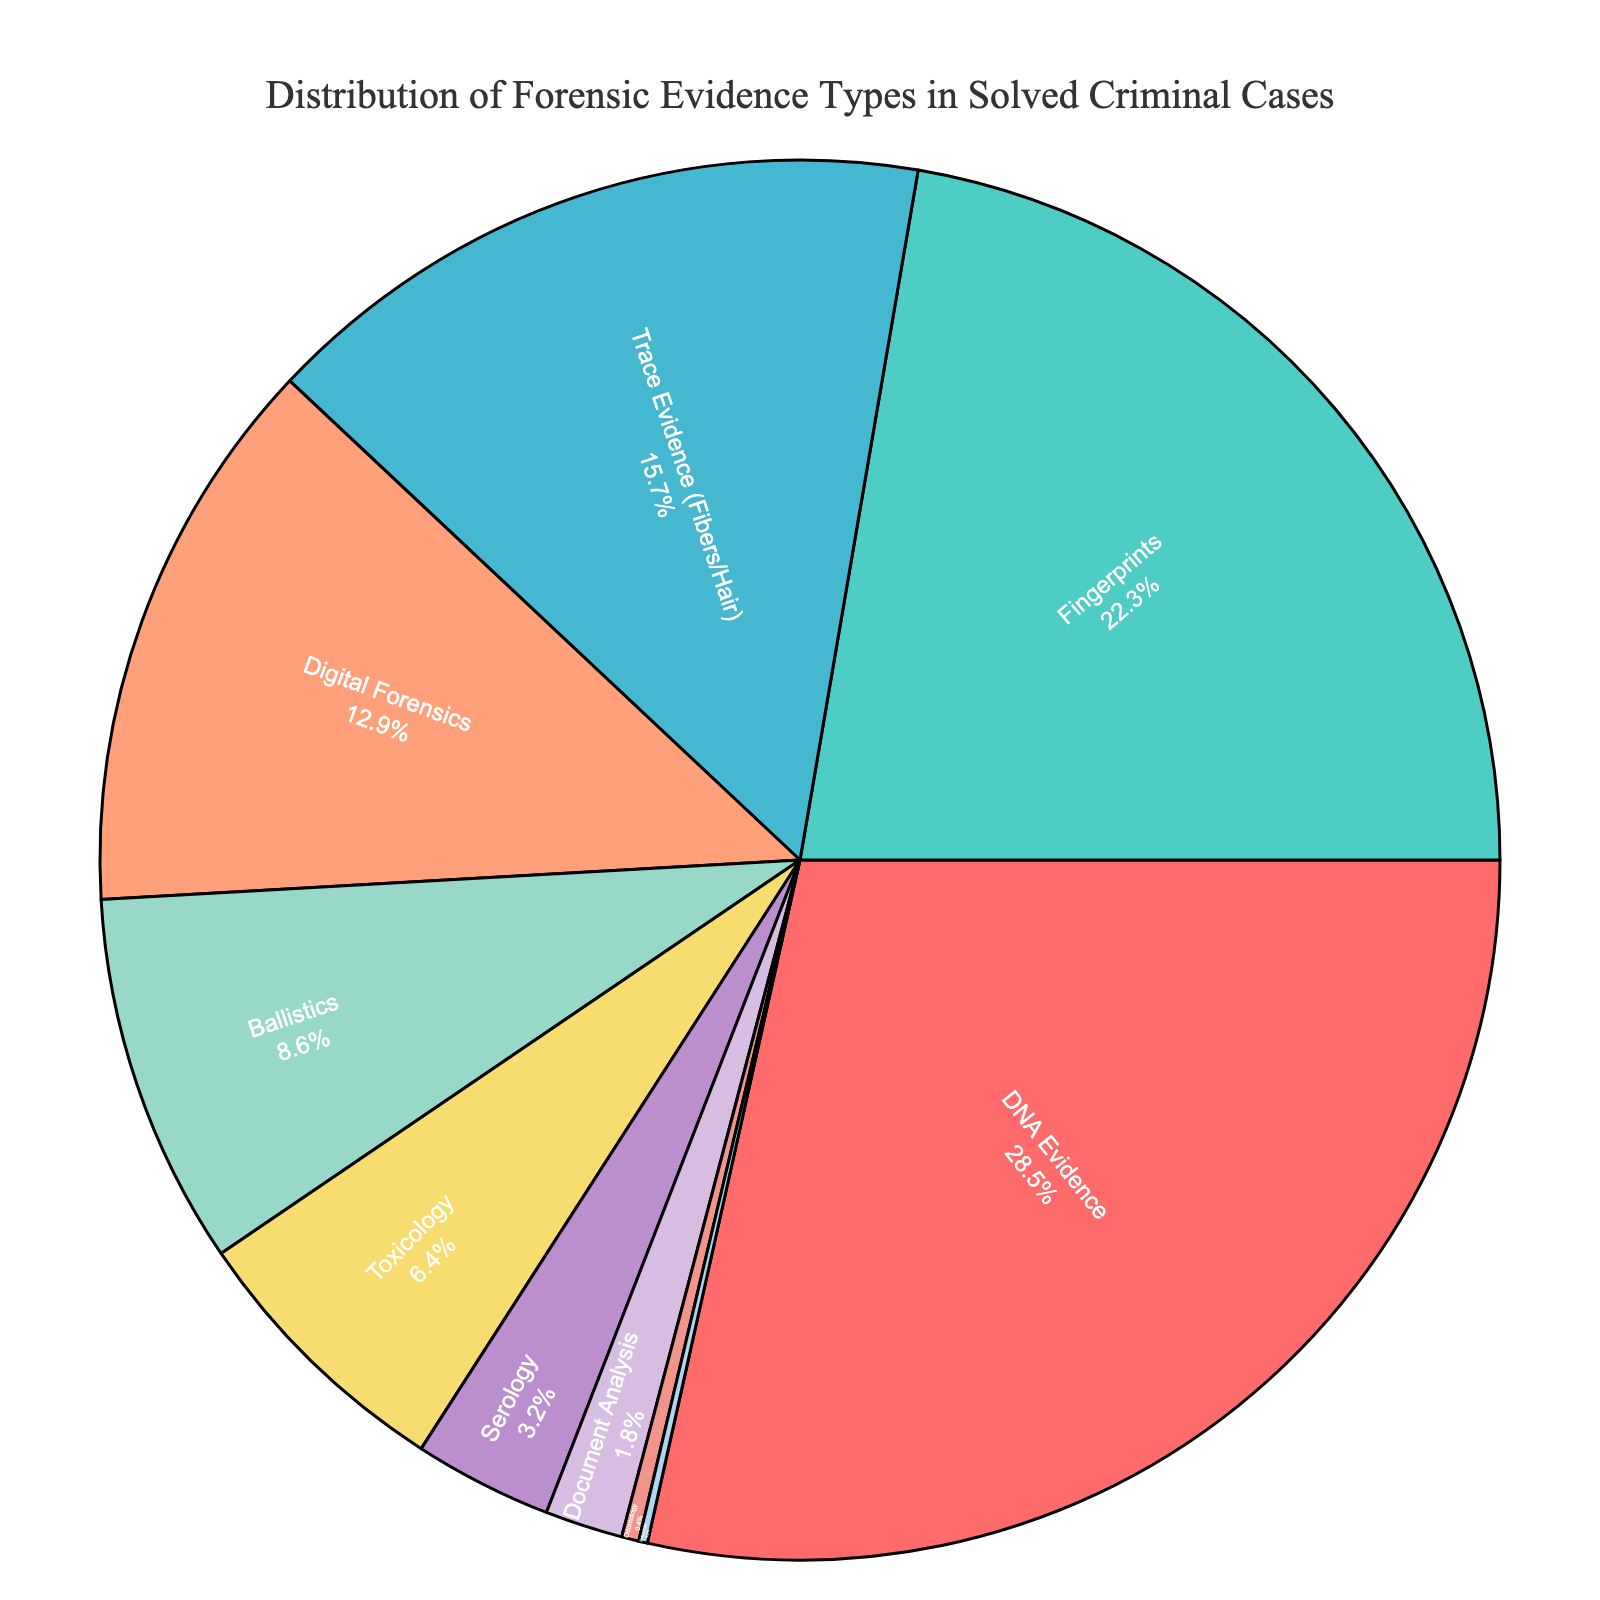What's the largest segment in the pie chart? The largest segment in the pie chart is represented by DNA Evidence, which has the highest percentage. This can be visually identified as the largest slice.
Answer: DNA Evidence Which evidence types have percentages greater than 20%? To identify percentages greater than 20%, you need to look at the labels and associated percentages on the pie chart. DNA Evidence (28.5%) and Fingerprints (22.3%) are the segments with percentages greater than 20%.
Answer: DNA Evidence, Fingerprints Which evidence type is represented by the smallest slice in the pie chart? The smallest slice in the pie chart is represented by Entomology, which has the lowest percentage at 0.2%. This can be visually identified as the smallest segment.
Answer: Entomology What is the combined percentage of Trace Evidence and Digital Forensics? To find the combined percentage, add the percentages of Trace Evidence (15.7%) and Digital Forensics (12.9%): 15.7 + 12.9 = 28.6%
Answer: 28.6% How does the percentage of Ballistics compare to Toxicology? The percentage of Ballistics is 8.6%, while Toxicology is 6.4%. Thus, Ballistics has a higher percentage than Toxicology.
Answer: Ballistics is higher What percentage of solved criminal cases involved Serology, Document Analysis, Odontology, and Entomology combined? Add the percentages of Serology (3.2%), Document Analysis (1.8%), Odontology (0.4%), and Entomology (0.2%): 3.2 + 1.8 + 0.4 + 0.2 = 5.6%
Answer: 5.6% Which evidence type is represented by the green color in the pie chart? By examining the colorful segments and matching them to their associated labels, we see that Fingerprints are represented by the green color in the pie chart.
Answer: Fingerprints Is there more percentage of Digital Forensics or Trace Evidence? The percentage of Digital Forensics is 12.9%, while Trace Evidence is 15.7%. Comparing the two, Trace Evidence has a higher percentage.
Answer: Trace Evidence What is the percentage difference between DNA Evidence and Ballistics? Subtract the percentage of Ballistics (8.6%) from DNA Evidence (28.5%): 28.5 - 8.6 = 19.9%
Answer: 19.9% What is the average percentage of the top three evidence types in the pie chart? Identify the top three evidence types: DNA Evidence (28.5%), Fingerprints (22.3%), and Trace Evidence (15.7%). Find their average: (28.5 + 22.3 + 15.7) / 3 = 66.5 / 3 = 22.17%
Answer: 22.17% 